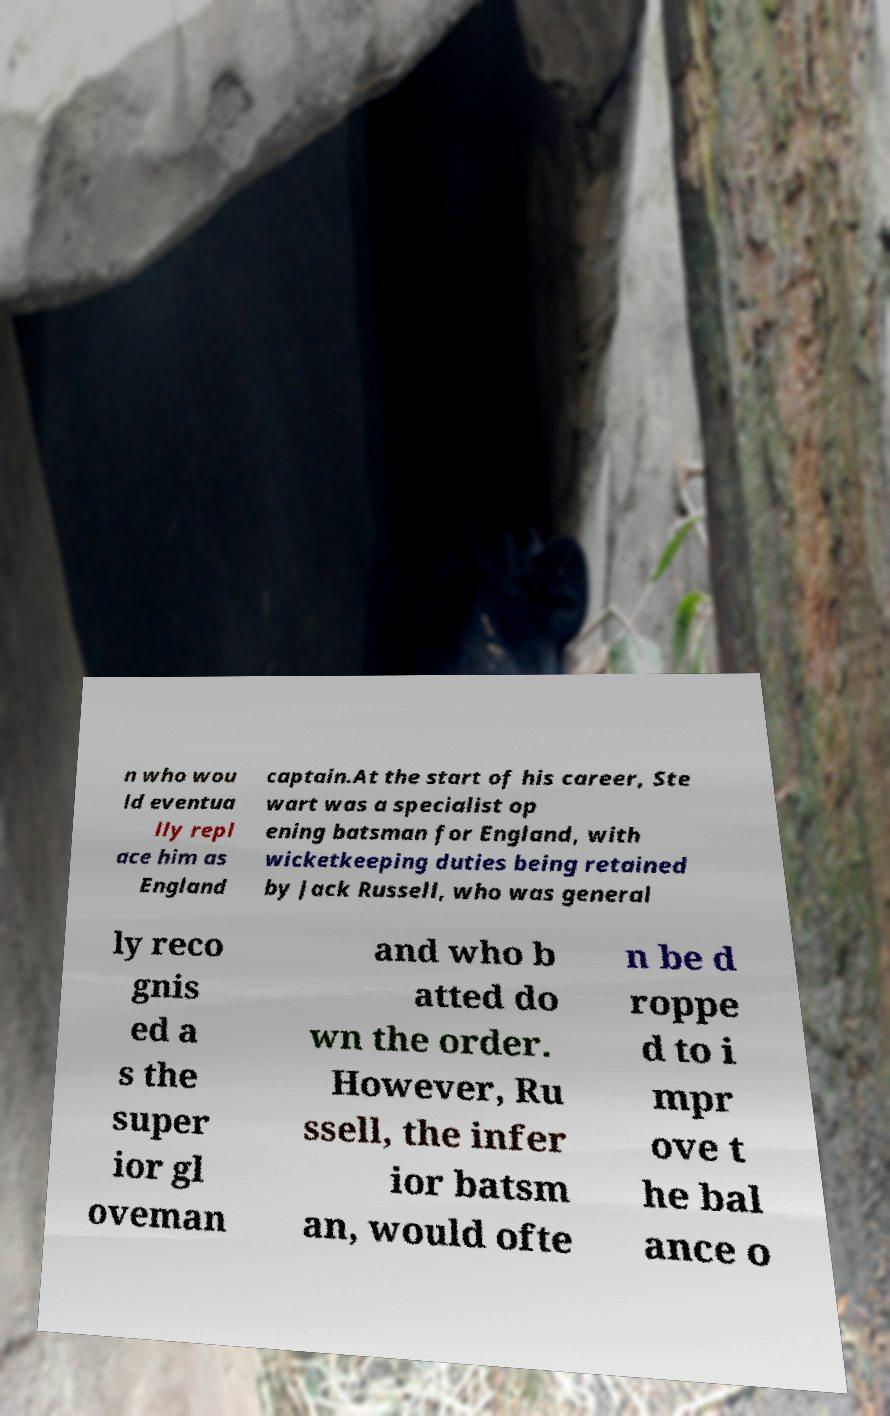I need the written content from this picture converted into text. Can you do that? n who wou ld eventua lly repl ace him as England captain.At the start of his career, Ste wart was a specialist op ening batsman for England, with wicketkeeping duties being retained by Jack Russell, who was general ly reco gnis ed a s the super ior gl oveman and who b atted do wn the order. However, Ru ssell, the infer ior batsm an, would ofte n be d roppe d to i mpr ove t he bal ance o 